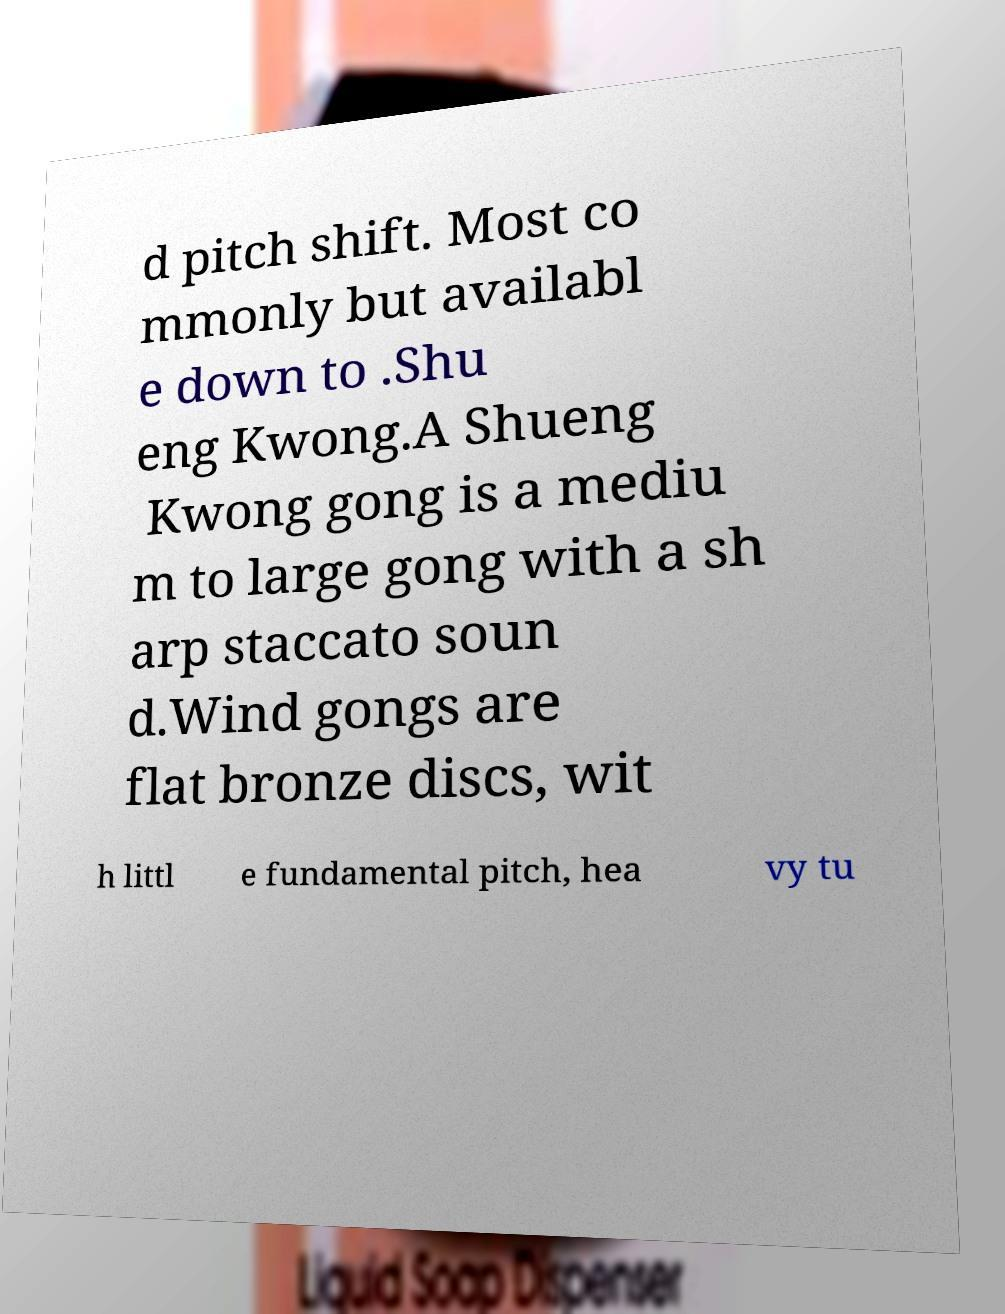Could you extract and type out the text from this image? d pitch shift. Most co mmonly but availabl e down to .Shu eng Kwong.A Shueng Kwong gong is a mediu m to large gong with a sh arp staccato soun d.Wind gongs are flat bronze discs, wit h littl e fundamental pitch, hea vy tu 